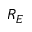<formula> <loc_0><loc_0><loc_500><loc_500>R _ { E }</formula> 